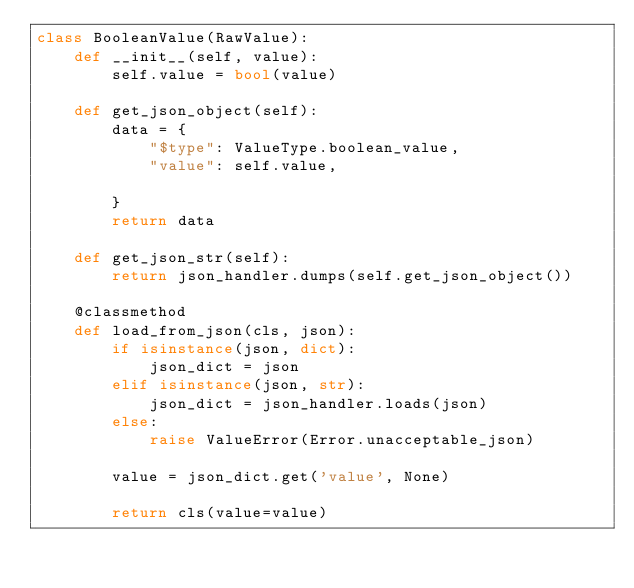<code> <loc_0><loc_0><loc_500><loc_500><_Python_>class BooleanValue(RawValue):
    def __init__(self, value):
        self.value = bool(value)

    def get_json_object(self):
        data = {
            "$type": ValueType.boolean_value,
            "value": self.value,

        }
        return data

    def get_json_str(self):
        return json_handler.dumps(self.get_json_object())

    @classmethod
    def load_from_json(cls, json):
        if isinstance(json, dict):
            json_dict = json
        elif isinstance(json, str):
            json_dict = json_handler.loads(json)
        else:
            raise ValueError(Error.unacceptable_json)

        value = json_dict.get('value', None)

        return cls(value=value)
</code> 